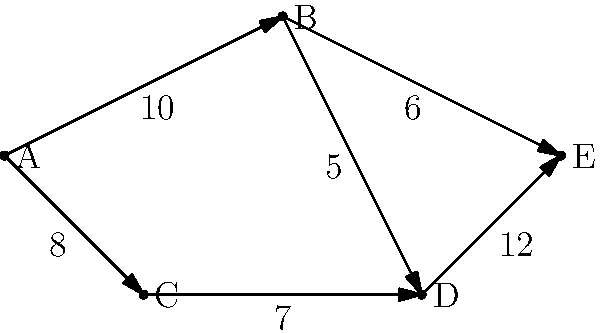As a leader implementing progressive water management policies, you're presented with a network flow chart representing a water distribution system. The nodes represent junctions, and the edges represent pipes with their maximum flow capacities (in million liters per day). What is the maximum amount of water that can be distributed from source A to destination E? To solve this problem, we'll use the Ford-Fulkerson algorithm to find the maximum flow in the network:

1. Identify all possible paths from A to E:
   Path 1: A -> B -> E
   Path 2: A -> B -> D -> E
   Path 3: A -> C -> D -> E

2. Find the bottleneck (minimum capacity) for each path:
   Path 1: min(10, 6) = 6
   Path 2: min(10, 5, 12) = 5
   Path 3: min(8, 7, 12) = 7

3. Start with the path with the largest bottleneck (Path 3):
   - Send 7 units of flow through A -> C -> D -> E
   - Remaining capacities: A->C: 1, C->D: 0, D->E: 5

4. Choose the next available path (Path 1):
   - Send 6 units of flow through A -> B -> E
   - Remaining capacities: A->B: 4, B->E: 0

5. The last path (Path 2) can't be used as B->D has no remaining capacity.

6. Sum up the flows:
   7 (from Path 3) + 6 (from Path 1) = 13

Therefore, the maximum amount of water that can be distributed from A to E is 13 million liters per day.
Answer: 13 million liters per day 